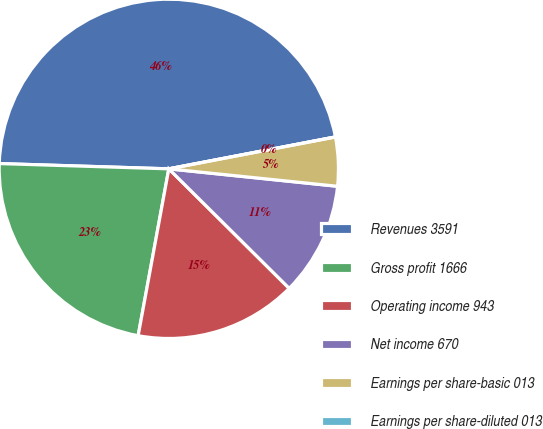Convert chart to OTSL. <chart><loc_0><loc_0><loc_500><loc_500><pie_chart><fcel>Revenues 3591<fcel>Gross profit 1666<fcel>Operating income 943<fcel>Net income 670<fcel>Earnings per share-basic 013<fcel>Earnings per share-diluted 013<nl><fcel>46.49%<fcel>22.6%<fcel>15.45%<fcel>10.8%<fcel>4.65%<fcel>0.0%<nl></chart> 